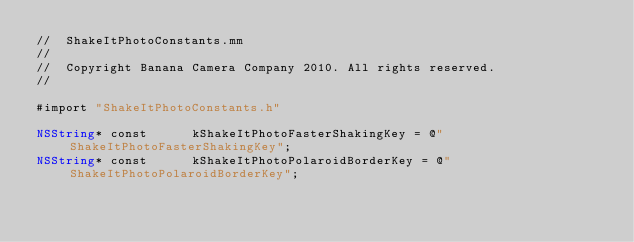Convert code to text. <code><loc_0><loc_0><loc_500><loc_500><_ObjectiveC_>//  ShakeItPhotoConstants.mm
//
//  Copyright Banana Camera Company 2010. All rights reserved.
//

#import "ShakeItPhotoConstants.h"

NSString* const      kShakeItPhotoFasterShakingKey = @"ShakeItPhotoFasterShakingKey";
NSString* const      kShakeItPhotoPolaroidBorderKey = @"ShakeItPhotoPolaroidBorderKey";
</code> 